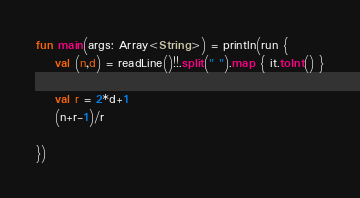<code> <loc_0><loc_0><loc_500><loc_500><_Kotlin_>fun main(args: Array<String>) = println(run {
    val (n,d) = readLine()!!.split(" ").map { it.toInt() }

    val r = 2*d+1
    (n+r-1)/r

})</code> 